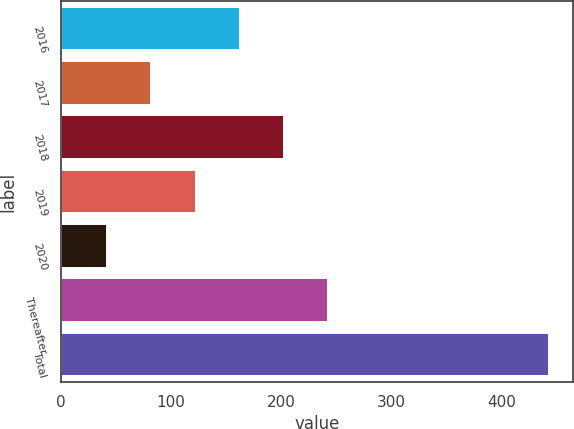Convert chart. <chart><loc_0><loc_0><loc_500><loc_500><bar_chart><fcel>2016<fcel>2017<fcel>2018<fcel>2019<fcel>2020<fcel>Thereafter<fcel>Total<nl><fcel>162.3<fcel>82.1<fcel>202.4<fcel>122.2<fcel>42<fcel>242.5<fcel>443<nl></chart> 